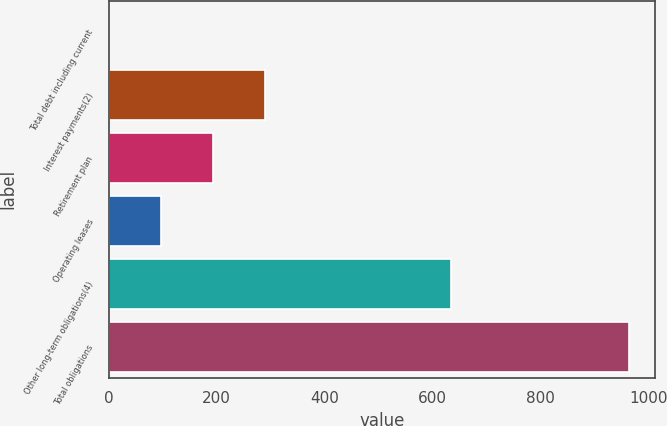<chart> <loc_0><loc_0><loc_500><loc_500><bar_chart><fcel>Total debt including current<fcel>Interest payments(2)<fcel>Retirement plan<fcel>Operating leases<fcel>Other long-term obligations(4)<fcel>Total obligations<nl><fcel>0.1<fcel>289.57<fcel>193.08<fcel>96.59<fcel>634<fcel>965<nl></chart> 